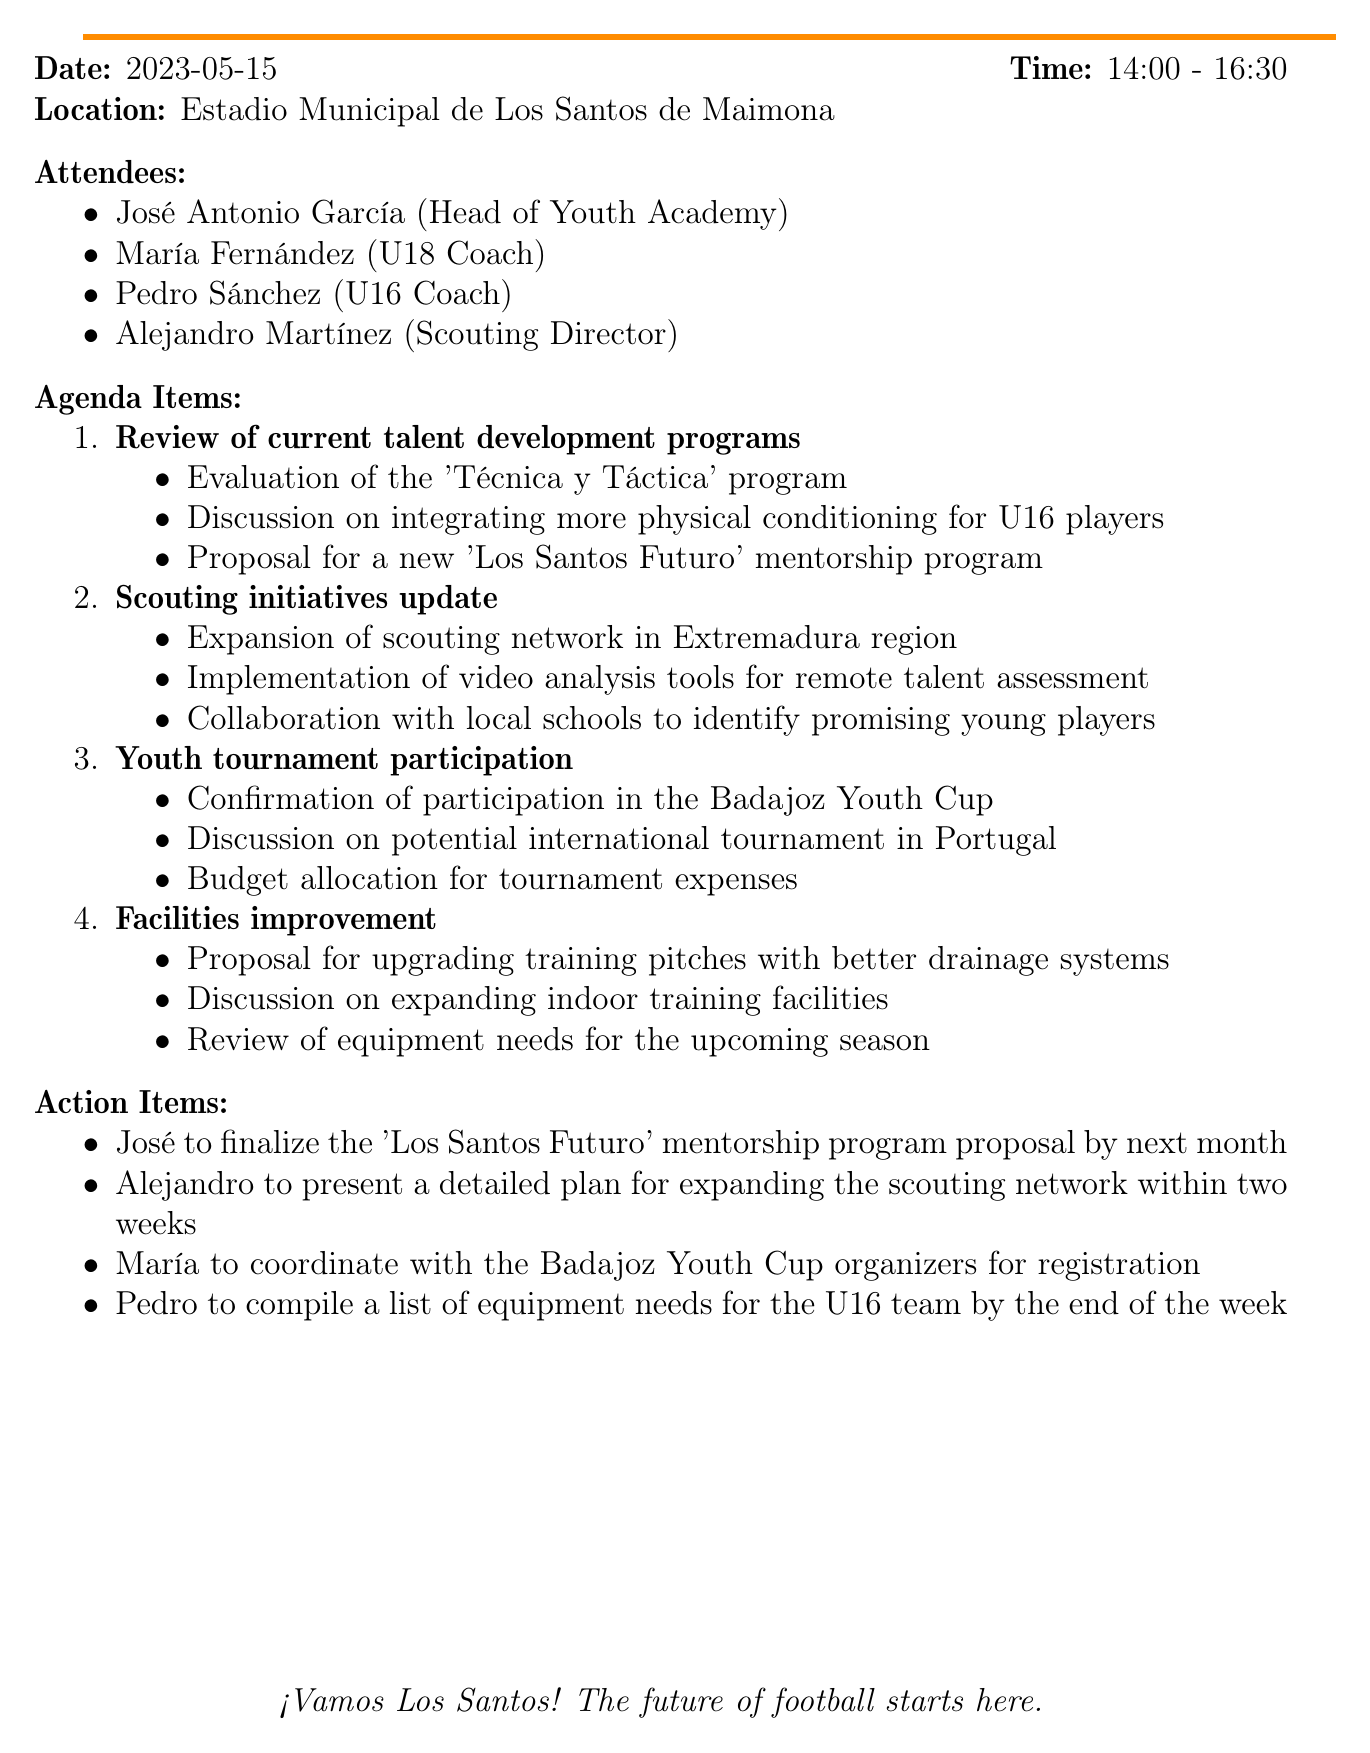What is the date of the meeting? The date of the meeting is mentioned clearly in the document as "2023-05-15".
Answer: 2023-05-15 Who is the Head of Youth Academy? The document lists attendees, and José Antonio García is identified as the Head of Youth Academy.
Answer: José Antonio García What is the time range of the meeting? The document specifies the meeting time as "14:00 - 16:30".
Answer: 14:00 - 16:30 What new program was proposed during the meeting? The agenda includes a proposal for the "Los Santos Futuro" mentorship program.
Answer: Los Santos Futuro Which tournament's participation was confirmed? The document mentions confirmation of participation in the "Badajoz Youth Cup".
Answer: Badajoz Youth Cup What is a key focus for U16 players discussed in talent development? There was a discussion about integrating "more physical conditioning" for U16 players in the development programs.
Answer: More physical conditioning What action is José assigned to complete? José is to finalize the "Los Santos Futuro" mentorship program proposal by next month.
Answer: Finalize the mentorship program proposal How many attendees were there? The document lists four attendees present at the meeting.
Answer: Four What is one way scouting initiatives are being improved? The document mentions the "implementation of video analysis tools for remote talent assessment" as a scouting improvement.
Answer: Video analysis tools 